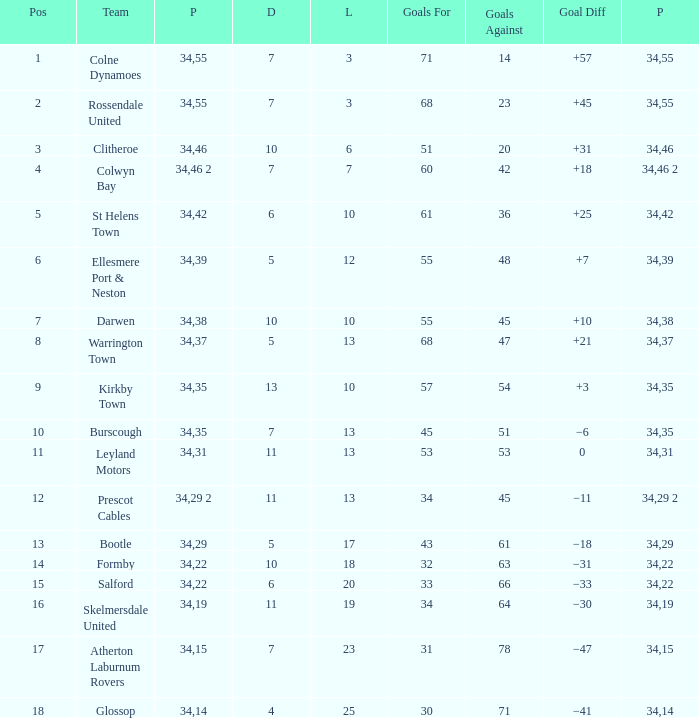Which Goals For has a Played larger than 34? None. 